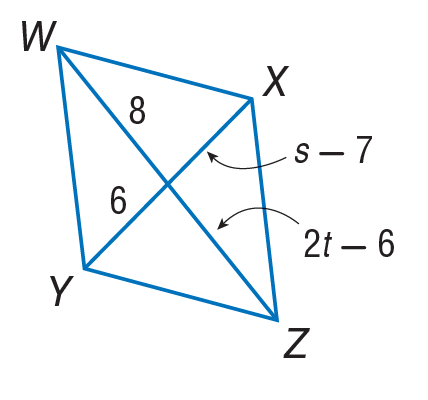Answer the mathemtical geometry problem and directly provide the correct option letter.
Question: Find the value of s in the parallelogram.
Choices: A: 6 B: 8 C: 13 D: 14 C 